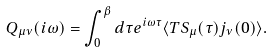Convert formula to latex. <formula><loc_0><loc_0><loc_500><loc_500>Q _ { \mu \nu } ( i \omega ) = \int _ { 0 } ^ { \beta } d \tau e ^ { i \omega \tau } \langle T S _ { \mu } ( \tau ) j _ { \nu } ( 0 ) \rangle .</formula> 